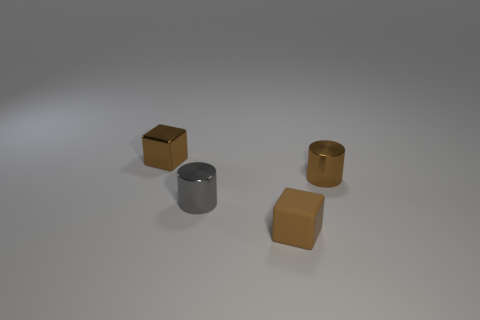What textures can be observed on these objects? The textures of the objects vary; the metallic blocks have a smooth, reflective surface, while the matte finish on the rubber block gives it a softer, less reflective texture. Could you describe the surface of the table on which these objects are resting? The surface upon which the objects are resting appears smooth with a diffuse reflection, suggesting a possibly satin or semi-matte finish with minimal texture. 